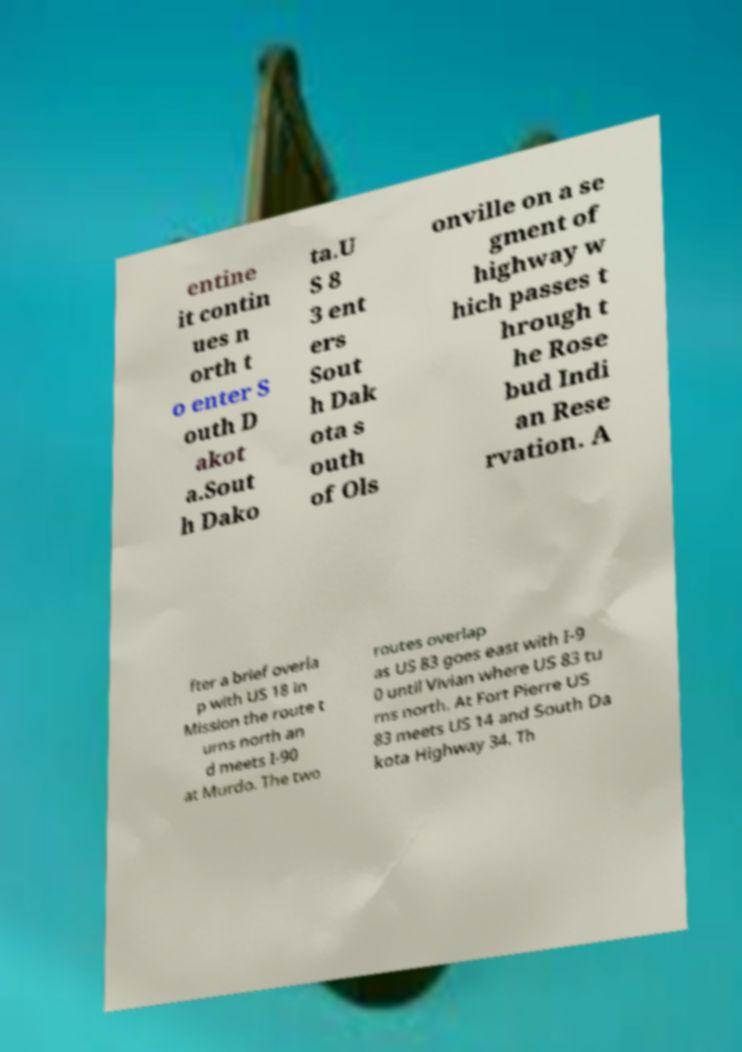I need the written content from this picture converted into text. Can you do that? entine it contin ues n orth t o enter S outh D akot a.Sout h Dako ta.U S 8 3 ent ers Sout h Dak ota s outh of Ols onville on a se gment of highway w hich passes t hrough t he Rose bud Indi an Rese rvation. A fter a brief overla p with US 18 in Mission the route t urns north an d meets I-90 at Murdo. The two routes overlap as US 83 goes east with I-9 0 until Vivian where US 83 tu rns north. At Fort Pierre US 83 meets US 14 and South Da kota Highway 34. Th 